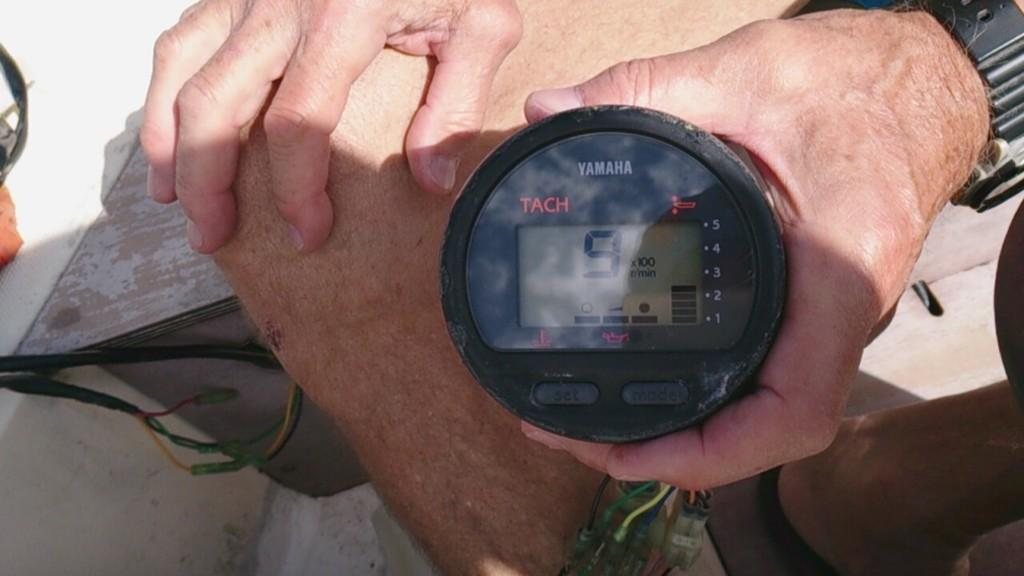Who is present in the image? There is a man in the image. What is the man holding in the image? The man is holding a tachometer. How is the tachometer being held by the man? The tachometer is being held with the man's hand. What else can be seen in the image besides the man and the tachometer? There are legs visible in the image, and there are wires on the left side of the image. What type of business is being suggested by the man in the image? There is no indication of a business or suggestion in the image; it simply shows a man holding a tachometer. 